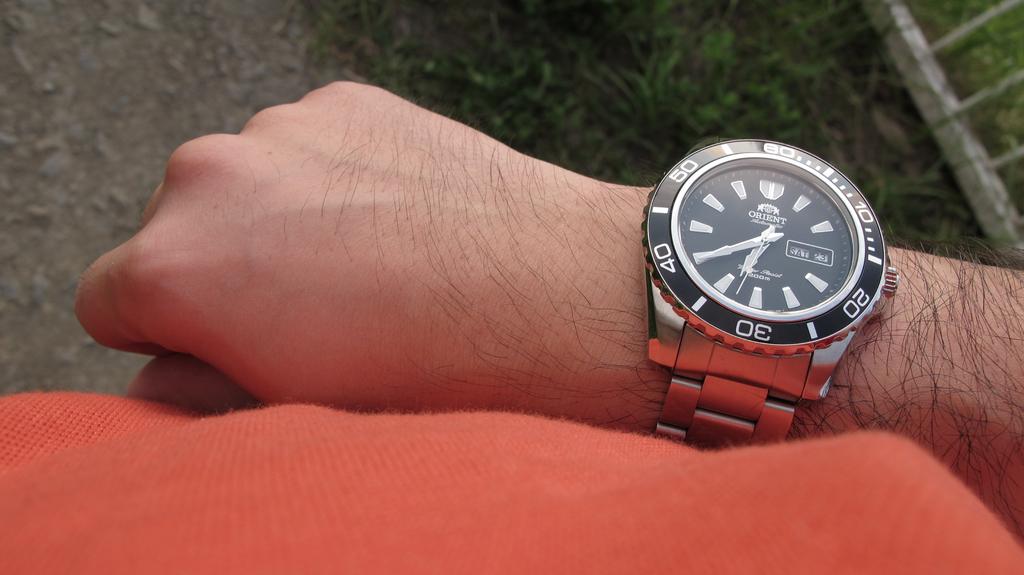What is the number closest to the bottom?
Provide a short and direct response. 30. 